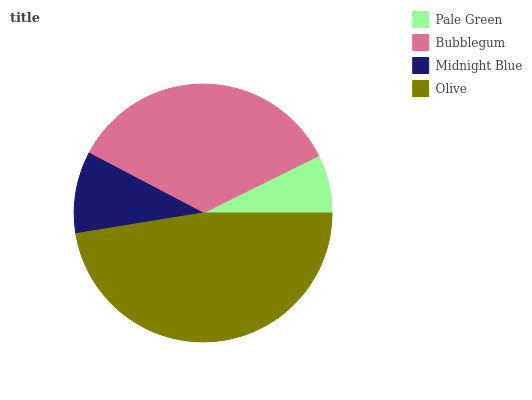Is Pale Green the minimum?
Answer yes or no. Yes. Is Olive the maximum?
Answer yes or no. Yes. Is Bubblegum the minimum?
Answer yes or no. No. Is Bubblegum the maximum?
Answer yes or no. No. Is Bubblegum greater than Pale Green?
Answer yes or no. Yes. Is Pale Green less than Bubblegum?
Answer yes or no. Yes. Is Pale Green greater than Bubblegum?
Answer yes or no. No. Is Bubblegum less than Pale Green?
Answer yes or no. No. Is Bubblegum the high median?
Answer yes or no. Yes. Is Midnight Blue the low median?
Answer yes or no. Yes. Is Pale Green the high median?
Answer yes or no. No. Is Bubblegum the low median?
Answer yes or no. No. 